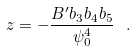<formula> <loc_0><loc_0><loc_500><loc_500>z = - \frac { B ^ { \prime } b _ { 3 } b _ { 4 } b _ { 5 } } { \psi _ { 0 } ^ { 4 } } \ .</formula> 